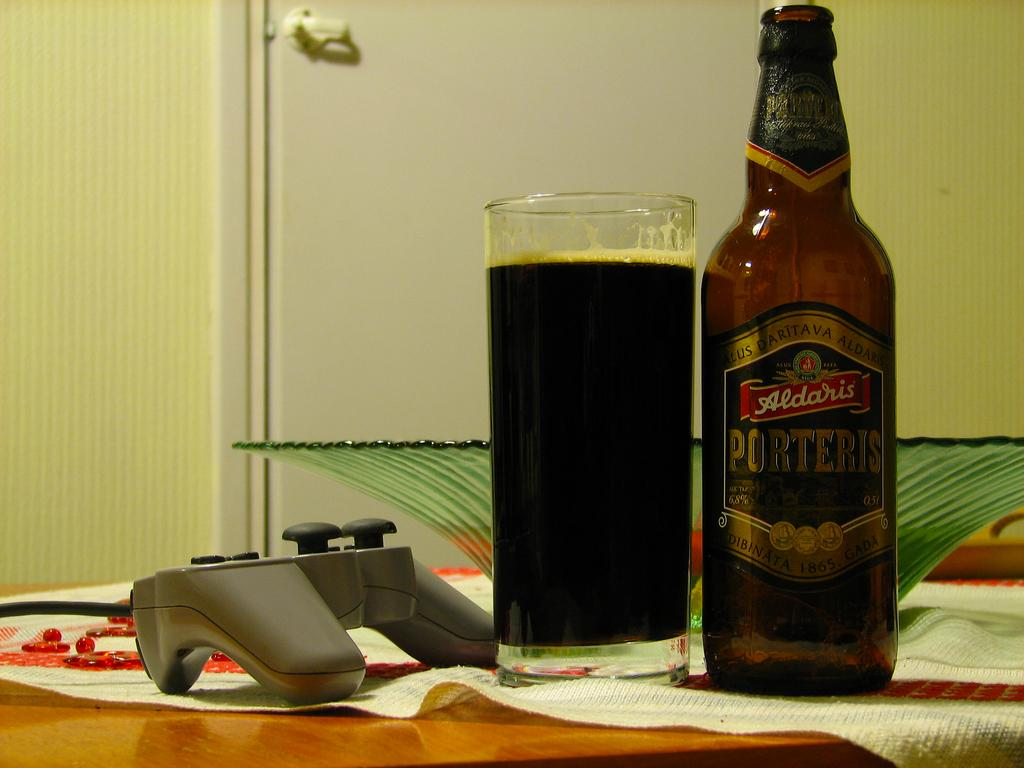What type of structure can be seen in the image? There is a wall in the image. What piece of furniture is present in the image? There is a table in the image. What objects are on the table? There is a bottle, a glass, a remote control, and a white color cloth on the table. What type of bells can be heard ringing in the image? There are no bells present in the image, and therefore no sound can be heard. What song is being played in the background of the image? There is no music or song playing in the image. 